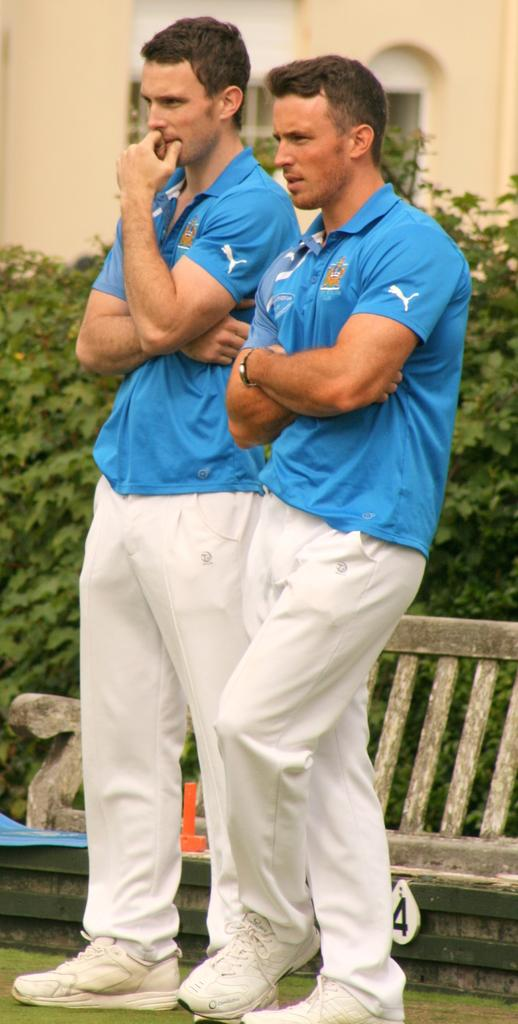How many people are in the image? There are two persons standing on the ground in the image. What can be seen in the background of the image? There is a fence, trees, and a building in the background of the image. What time of day was the image likely taken? The image was likely taken during the day, as there is sufficient light to see the details clearly. What type of jewel is the person wearing on their head in the image? There is no person wearing a jewel on their head in the image; the persons are not wearing any headgear or accessories. 